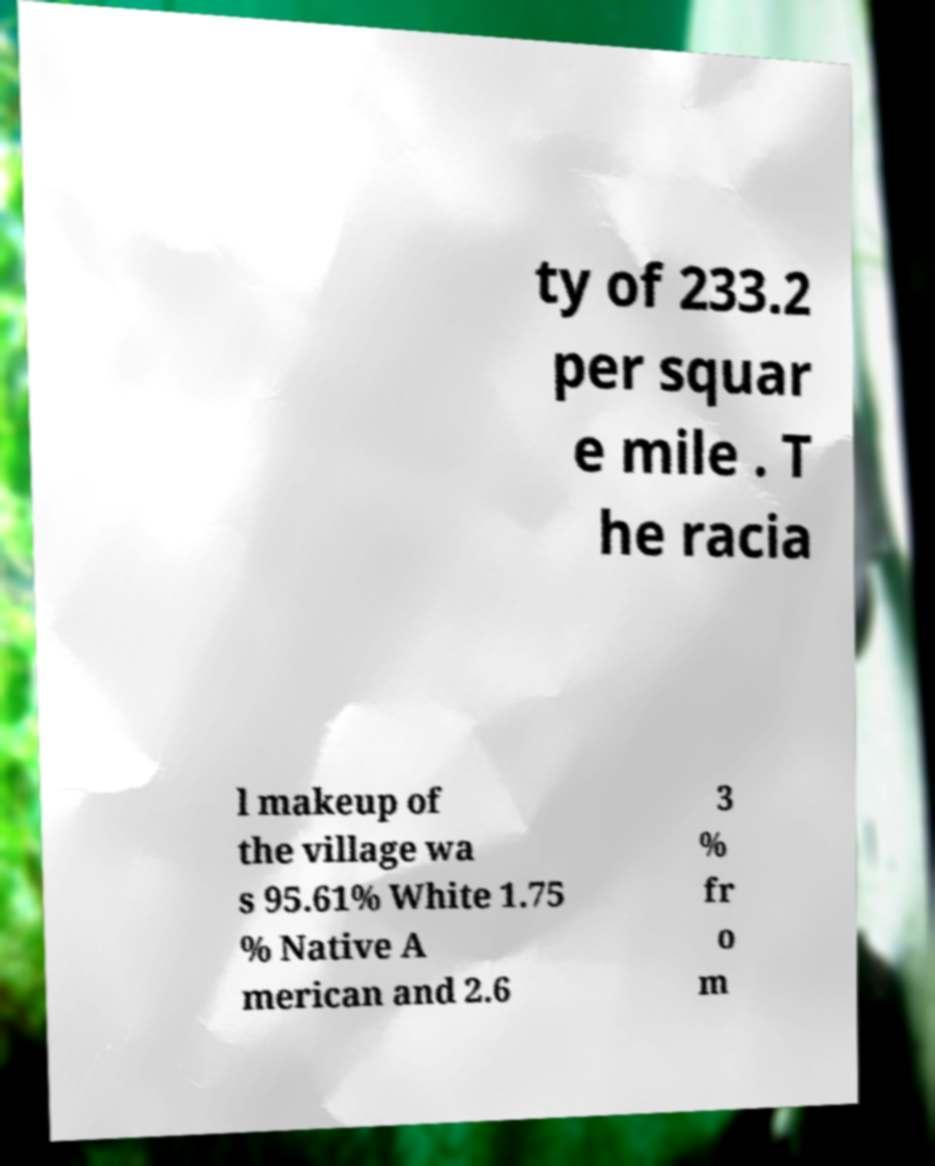What messages or text are displayed in this image? I need them in a readable, typed format. ty of 233.2 per squar e mile . T he racia l makeup of the village wa s 95.61% White 1.75 % Native A merican and 2.6 3 % fr o m 